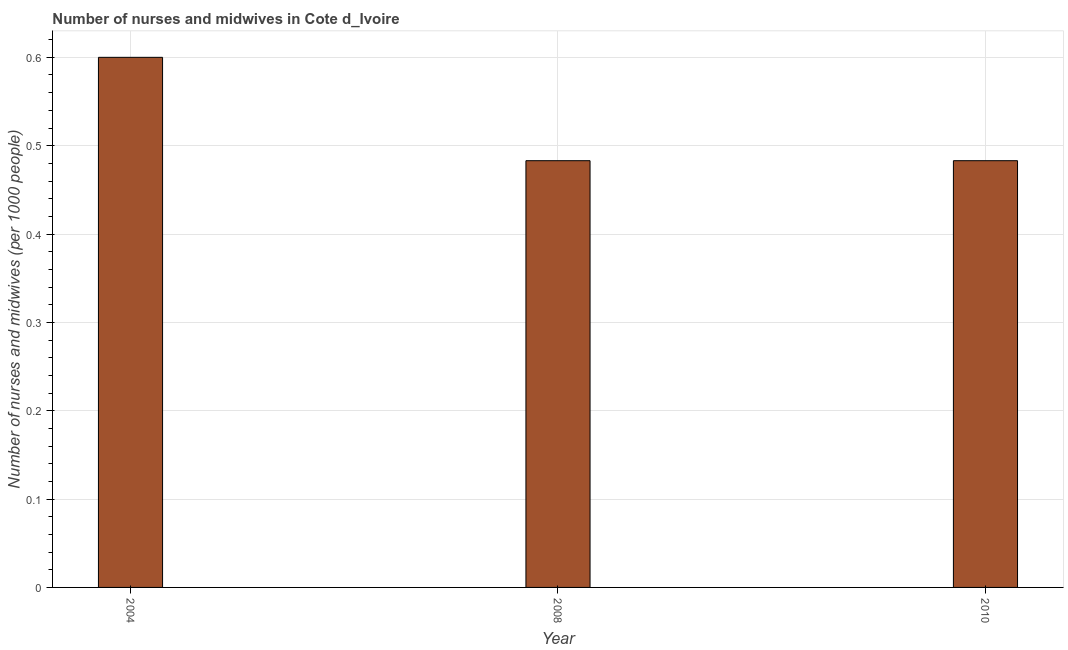Does the graph contain any zero values?
Provide a short and direct response. No. Does the graph contain grids?
Provide a succinct answer. Yes. What is the title of the graph?
Provide a succinct answer. Number of nurses and midwives in Cote d_Ivoire. What is the label or title of the X-axis?
Make the answer very short. Year. What is the label or title of the Y-axis?
Your response must be concise. Number of nurses and midwives (per 1000 people). What is the number of nurses and midwives in 2010?
Make the answer very short. 0.48. Across all years, what is the minimum number of nurses and midwives?
Offer a terse response. 0.48. What is the sum of the number of nurses and midwives?
Make the answer very short. 1.57. What is the average number of nurses and midwives per year?
Offer a terse response. 0.52. What is the median number of nurses and midwives?
Make the answer very short. 0.48. What is the ratio of the number of nurses and midwives in 2004 to that in 2008?
Ensure brevity in your answer.  1.24. Is the number of nurses and midwives in 2008 less than that in 2010?
Give a very brief answer. No. Is the difference between the number of nurses and midwives in 2004 and 2010 greater than the difference between any two years?
Offer a terse response. Yes. What is the difference between the highest and the second highest number of nurses and midwives?
Make the answer very short. 0.12. What is the difference between the highest and the lowest number of nurses and midwives?
Give a very brief answer. 0.12. In how many years, is the number of nurses and midwives greater than the average number of nurses and midwives taken over all years?
Provide a short and direct response. 1. How many bars are there?
Keep it short and to the point. 3. What is the Number of nurses and midwives (per 1000 people) of 2008?
Your answer should be compact. 0.48. What is the Number of nurses and midwives (per 1000 people) of 2010?
Ensure brevity in your answer.  0.48. What is the difference between the Number of nurses and midwives (per 1000 people) in 2004 and 2008?
Offer a very short reply. 0.12. What is the difference between the Number of nurses and midwives (per 1000 people) in 2004 and 2010?
Offer a very short reply. 0.12. What is the difference between the Number of nurses and midwives (per 1000 people) in 2008 and 2010?
Provide a short and direct response. 0. What is the ratio of the Number of nurses and midwives (per 1000 people) in 2004 to that in 2008?
Give a very brief answer. 1.24. What is the ratio of the Number of nurses and midwives (per 1000 people) in 2004 to that in 2010?
Your answer should be very brief. 1.24. 